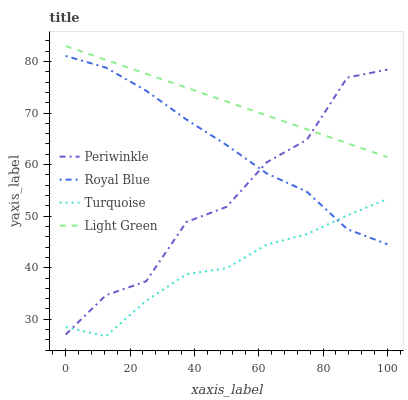Does Turquoise have the minimum area under the curve?
Answer yes or no. Yes. Does Light Green have the maximum area under the curve?
Answer yes or no. Yes. Does Periwinkle have the minimum area under the curve?
Answer yes or no. No. Does Periwinkle have the maximum area under the curve?
Answer yes or no. No. Is Light Green the smoothest?
Answer yes or no. Yes. Is Periwinkle the roughest?
Answer yes or no. Yes. Is Turquoise the smoothest?
Answer yes or no. No. Is Turquoise the roughest?
Answer yes or no. No. Does Turquoise have the lowest value?
Answer yes or no. Yes. Does Periwinkle have the lowest value?
Answer yes or no. No. Does Light Green have the highest value?
Answer yes or no. Yes. Does Periwinkle have the highest value?
Answer yes or no. No. Is Royal Blue less than Light Green?
Answer yes or no. Yes. Is Light Green greater than Turquoise?
Answer yes or no. Yes. Does Periwinkle intersect Light Green?
Answer yes or no. Yes. Is Periwinkle less than Light Green?
Answer yes or no. No. Is Periwinkle greater than Light Green?
Answer yes or no. No. Does Royal Blue intersect Light Green?
Answer yes or no. No. 